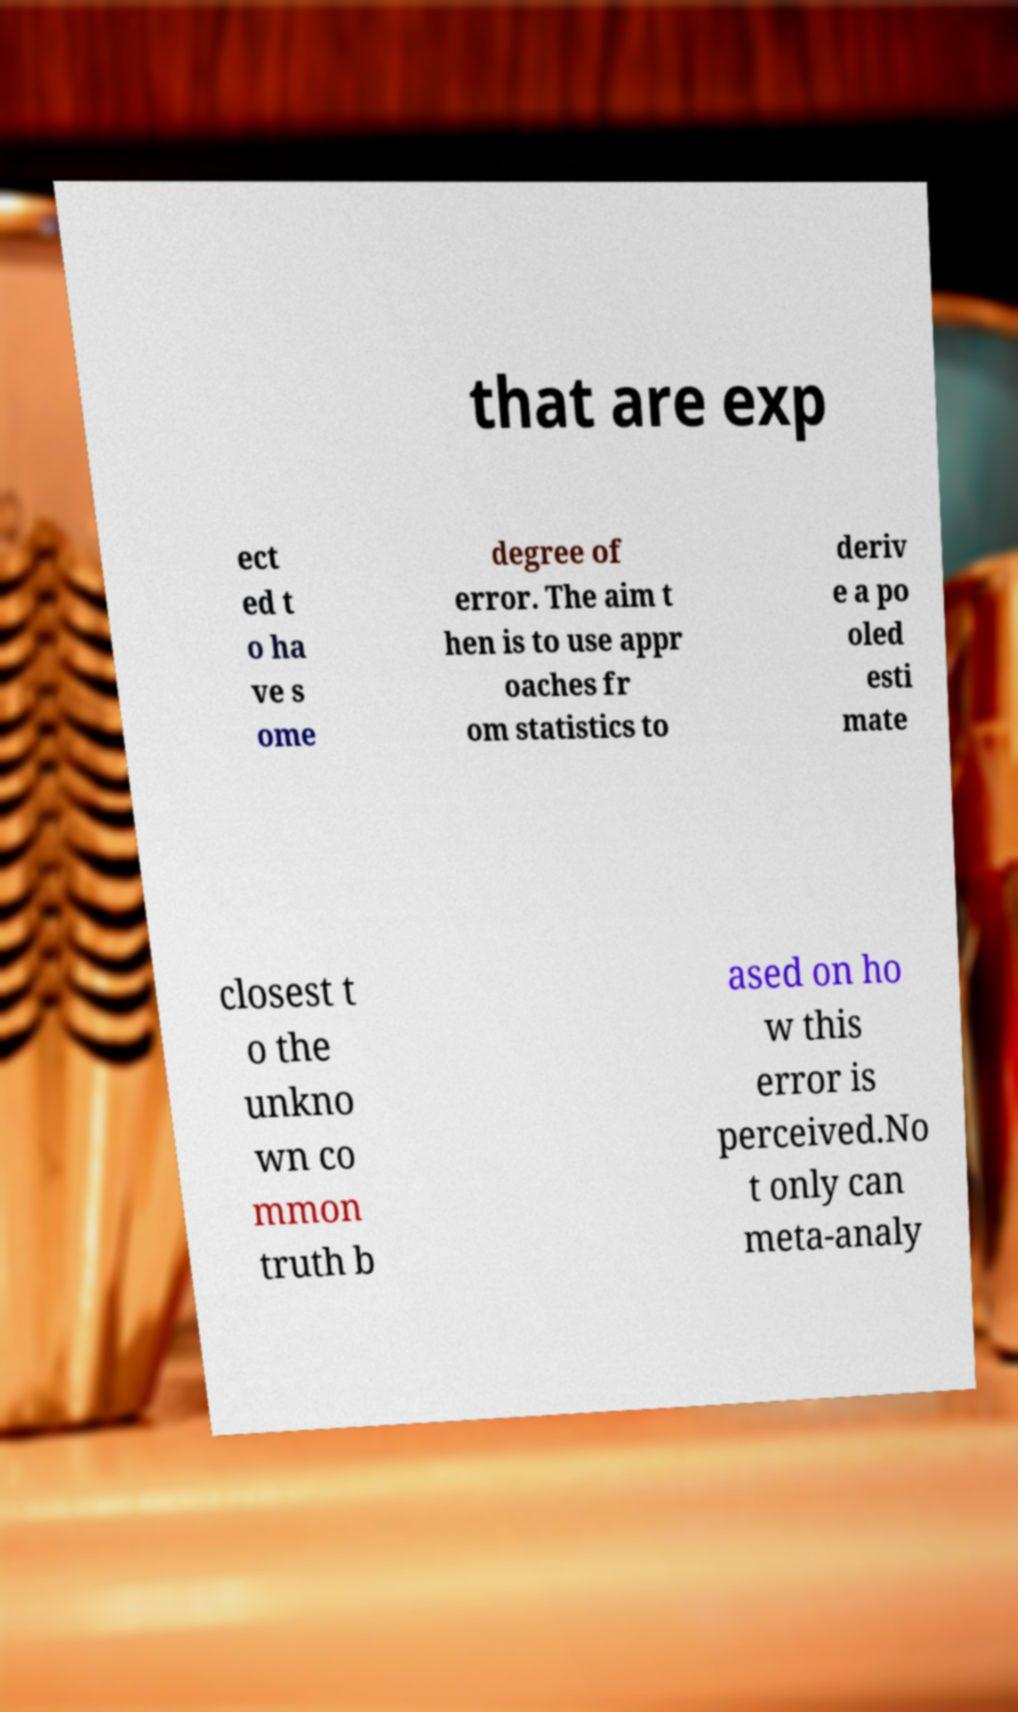I need the written content from this picture converted into text. Can you do that? that are exp ect ed t o ha ve s ome degree of error. The aim t hen is to use appr oaches fr om statistics to deriv e a po oled esti mate closest t o the unkno wn co mmon truth b ased on ho w this error is perceived.No t only can meta-analy 